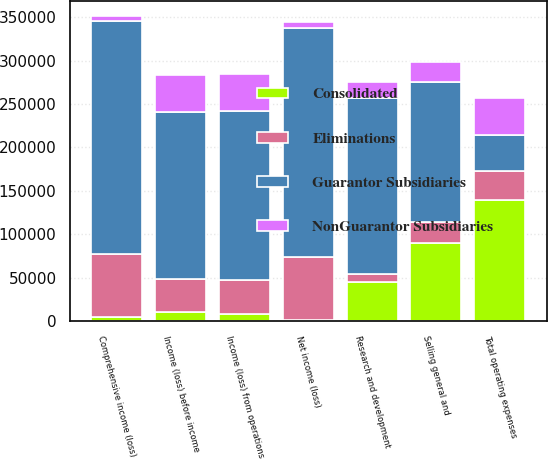<chart> <loc_0><loc_0><loc_500><loc_500><stacked_bar_chart><ecel><fcel>Research and development<fcel>Selling general and<fcel>Total operating expenses<fcel>Income (loss) from operations<fcel>Income (loss) before income<fcel>Net income (loss)<fcel>Comprehensive income (loss)<nl><fcel>NonGuarantor Subsidiaries<fcel>18335<fcel>23776<fcel>42111<fcel>42111<fcel>42111<fcel>6482<fcel>6482<nl><fcel>Guarantor Subsidiaries<fcel>202337<fcel>160538<fcel>42111<fcel>194549<fcel>191882<fcel>263804<fcel>267724<nl><fcel>Consolidated<fcel>45751<fcel>90055<fcel>139281<fcel>8818<fcel>10210<fcel>1346<fcel>4605<nl><fcel>Eliminations<fcel>8929<fcel>24483<fcel>33199<fcel>38790<fcel>38740<fcel>72634<fcel>72637<nl></chart> 